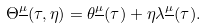<formula> <loc_0><loc_0><loc_500><loc_500>\Theta ^ { \underline { \mu } } ( \tau , \eta ) = \theta ^ { \underline { \mu } } ( \tau ) + \eta \lambda ^ { \underline { \mu } } ( \tau ) .</formula> 